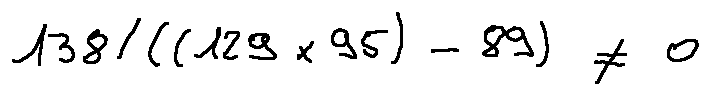<formula> <loc_0><loc_0><loc_500><loc_500>1 3 8 / ( ( 1 2 9 \times 9 5 ) - 8 9 ) \neq 0</formula> 